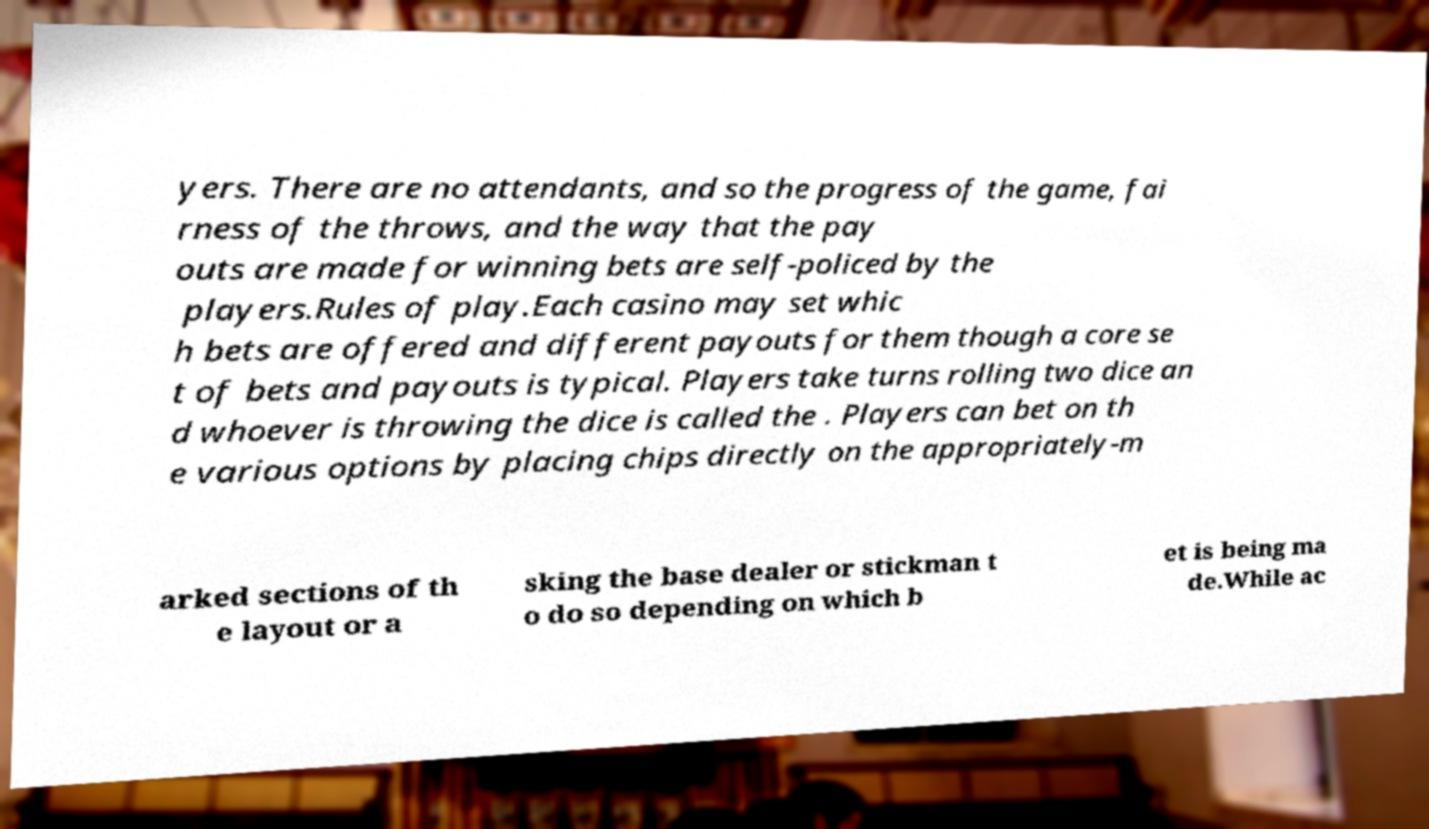Please identify and transcribe the text found in this image. yers. There are no attendants, and so the progress of the game, fai rness of the throws, and the way that the pay outs are made for winning bets are self-policed by the players.Rules of play.Each casino may set whic h bets are offered and different payouts for them though a core se t of bets and payouts is typical. Players take turns rolling two dice an d whoever is throwing the dice is called the . Players can bet on th e various options by placing chips directly on the appropriately-m arked sections of th e layout or a sking the base dealer or stickman t o do so depending on which b et is being ma de.While ac 